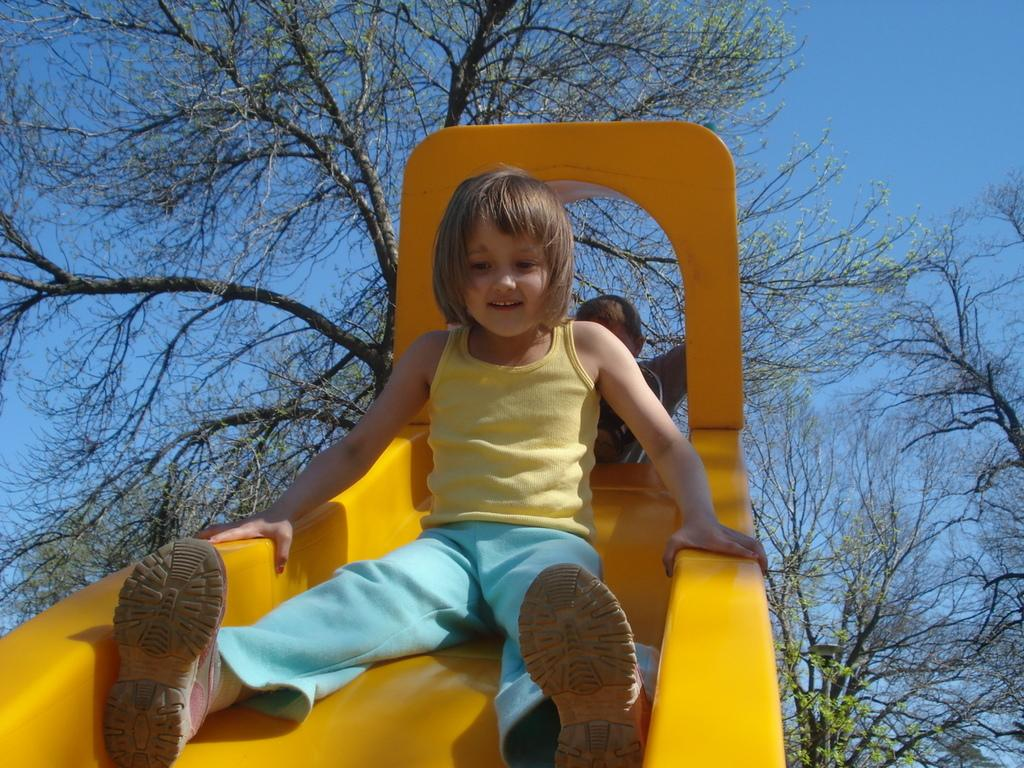What type of equipment is present in the image? There is playground equipment in the image. Can you describe the children in the image? There is a girl child and another child in the image. What can be seen in the background of the image? There are trees and the sky visible in the background of the image. What type of food is being served on the ice in the image? There is no food or ice present in the image; it features playground equipment, children, trees, and the sky. 